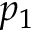<formula> <loc_0><loc_0><loc_500><loc_500>p _ { 1 }</formula> 